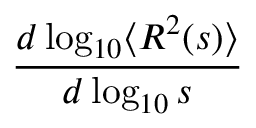Convert formula to latex. <formula><loc_0><loc_0><loc_500><loc_500>\frac { d \log _ { 1 0 } \langle R ^ { 2 } ( s ) \rangle } { d \log _ { 1 0 } s }</formula> 